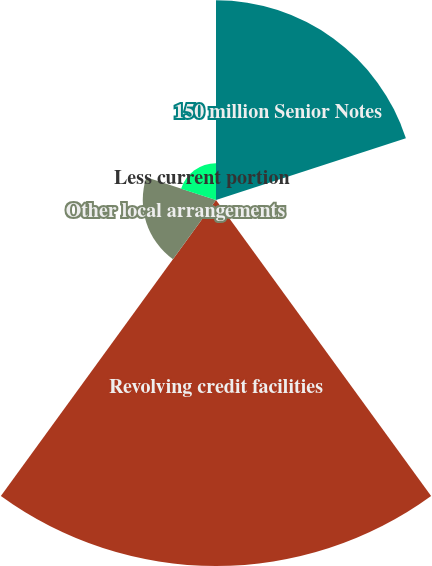<chart> <loc_0><loc_0><loc_500><loc_500><pie_chart><fcel>150 million Senior Notes<fcel>Less unamortized discount<fcel>Revolving credit facilities<fcel>Other local arrangements<fcel>Less current portion<nl><fcel>29.55%<fcel>0.01%<fcel>54.17%<fcel>10.84%<fcel>5.43%<nl></chart> 